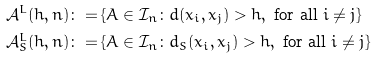Convert formula to latex. <formula><loc_0><loc_0><loc_500><loc_500>\mathcal { A } ^ { L } ( h , n ) \colon = & \left \{ A \in \mathcal { I } _ { n } \colon d ( x _ { i } , x _ { j } ) > h , \text { for all } i \neq j \right \} \\ \mathcal { A } _ { S } ^ { L } ( h , n ) \colon = & \left \{ A \in \mathcal { I } _ { n } \colon d _ { S } ( x _ { i } , x _ { j } ) > h , \text { for all } i \neq j \right \} \</formula> 